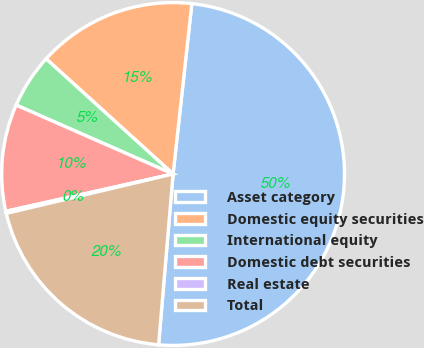Convert chart to OTSL. <chart><loc_0><loc_0><loc_500><loc_500><pie_chart><fcel>Asset category<fcel>Domestic equity securities<fcel>International equity<fcel>Domestic debt securities<fcel>Real estate<fcel>Total<nl><fcel>49.6%<fcel>15.02%<fcel>5.14%<fcel>10.08%<fcel>0.2%<fcel>19.96%<nl></chart> 